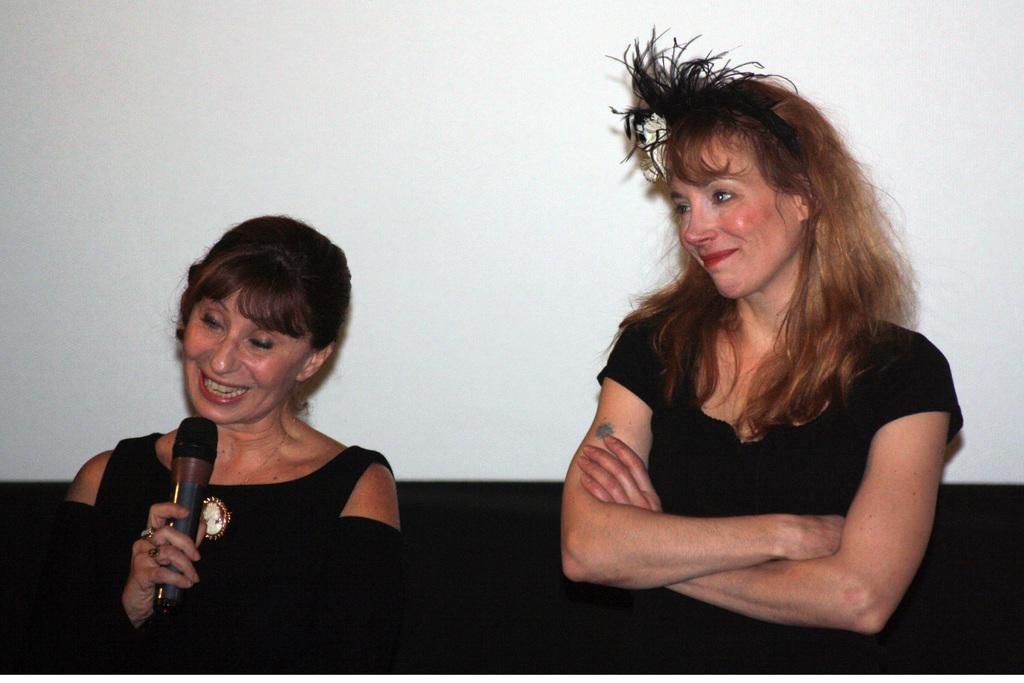How many women are in the image? There are two women in the image. What are the women doing in the image? One woman is standing and smiling, while the other woman is standing and speaking into a microphone. What color dresses are the women wearing? Both women are wearing black color dresses. Can you tell me how many grandmothers are present in the image? There is no mention of grandmothers in the image, so it cannot be determined from the provided facts. What type of desk can be seen in the image? There is no desk present in the image. 